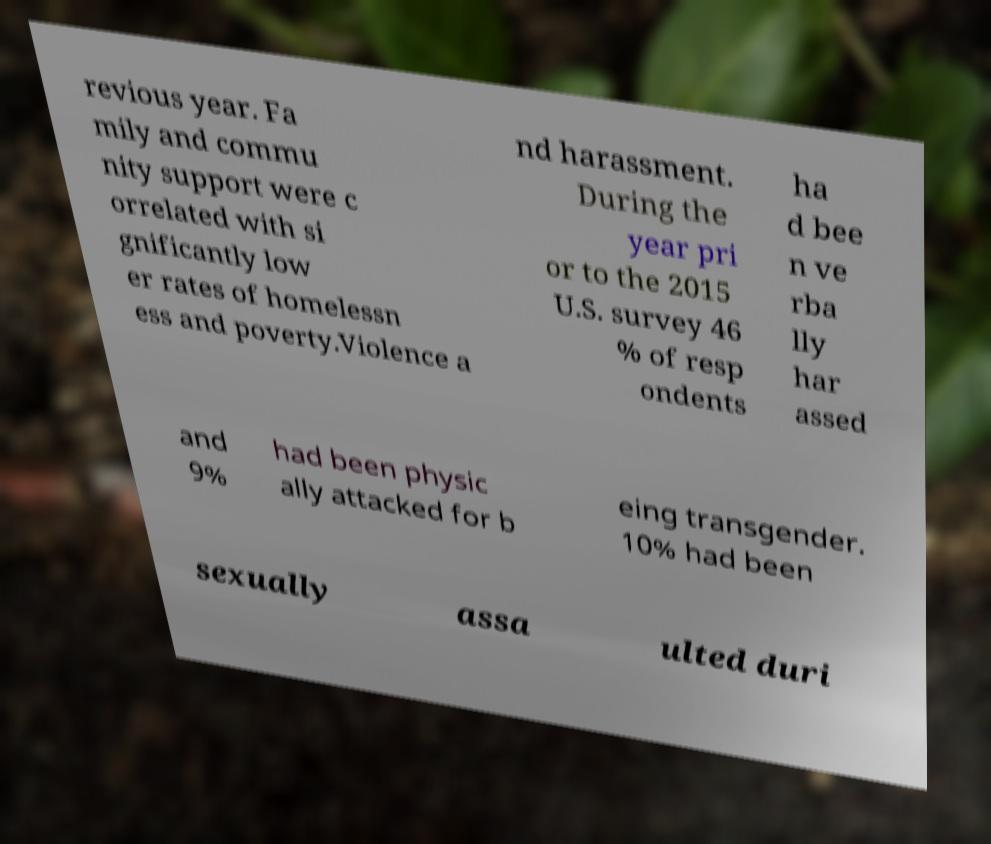For documentation purposes, I need the text within this image transcribed. Could you provide that? revious year. Fa mily and commu nity support were c orrelated with si gnificantly low er rates of homelessn ess and poverty.Violence a nd harassment. During the year pri or to the 2015 U.S. survey 46 % of resp ondents ha d bee n ve rba lly har assed and 9% had been physic ally attacked for b eing transgender. 10% had been sexually assa ulted duri 